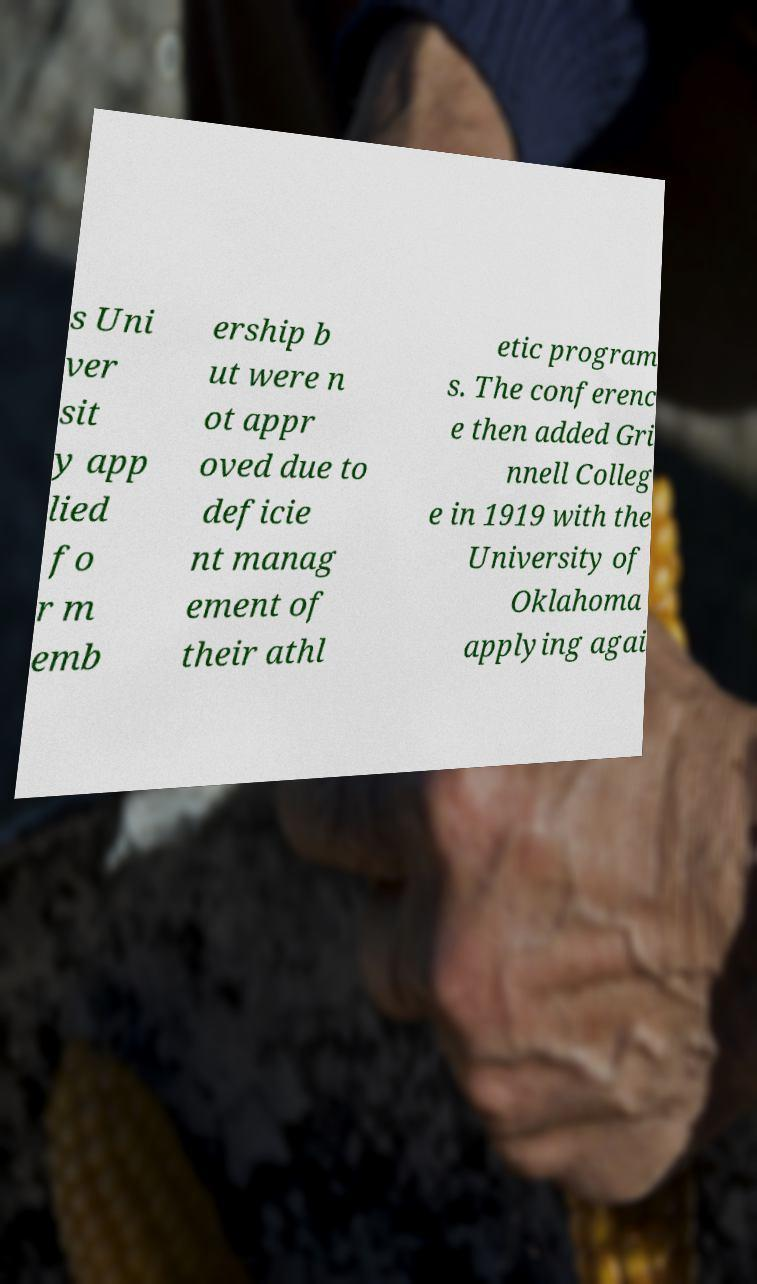Could you extract and type out the text from this image? s Uni ver sit y app lied fo r m emb ership b ut were n ot appr oved due to deficie nt manag ement of their athl etic program s. The conferenc e then added Gri nnell Colleg e in 1919 with the University of Oklahoma applying agai 